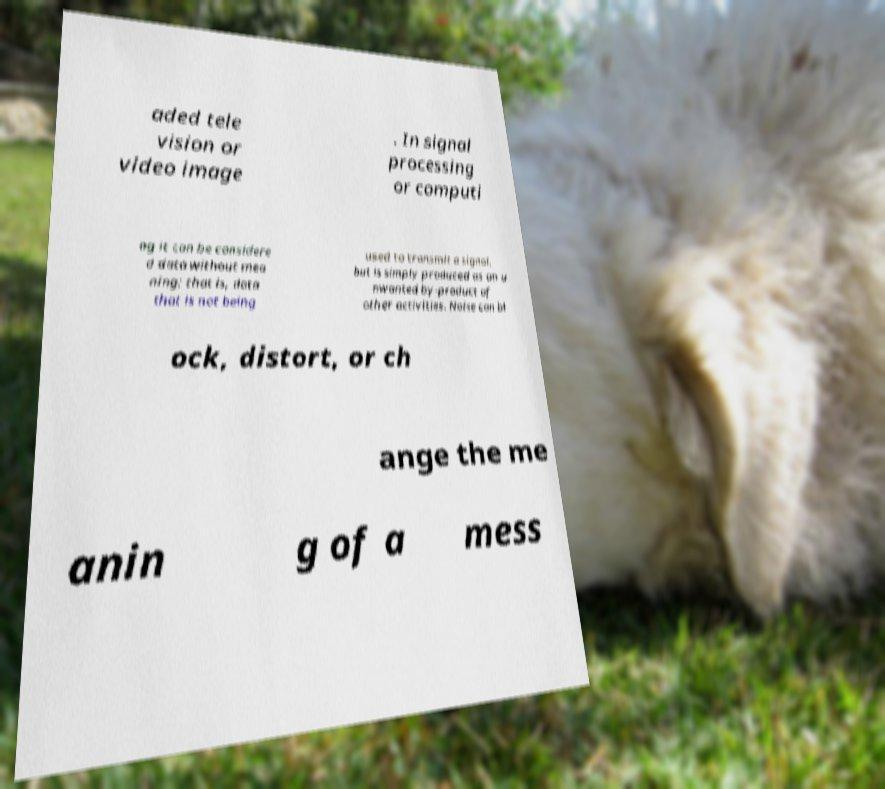Could you assist in decoding the text presented in this image and type it out clearly? aded tele vision or video image . In signal processing or computi ng it can be considere d data without mea ning; that is, data that is not being used to transmit a signal, but is simply produced as an u nwanted by-product of other activities. Noise can bl ock, distort, or ch ange the me anin g of a mess 